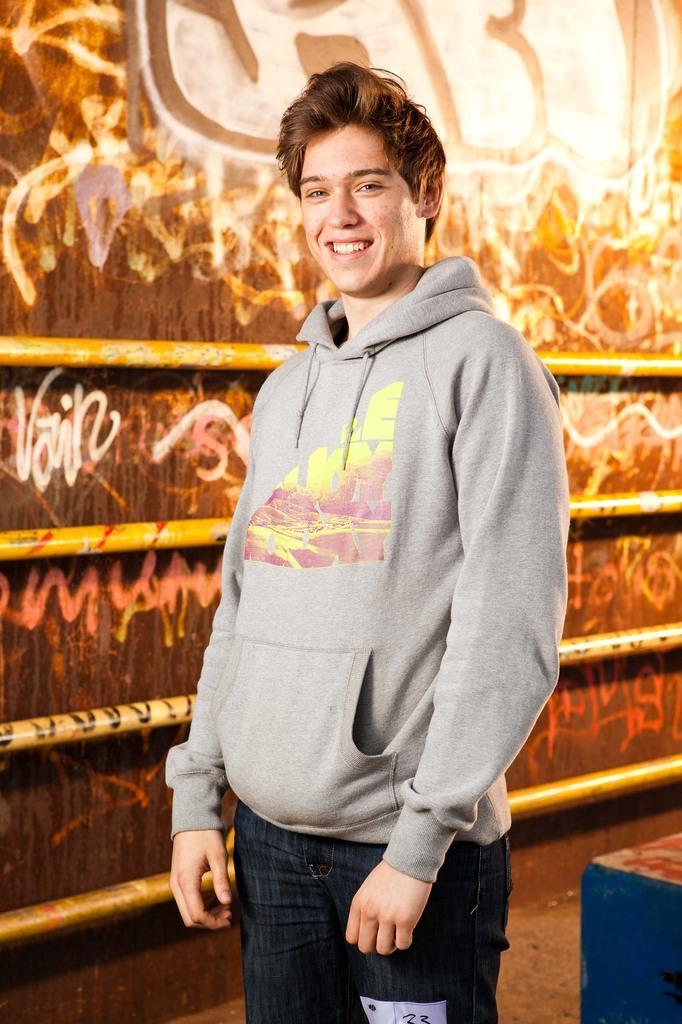Describe this image in one or two sentences. In this image, we can see a person standing. In the background, we can see the wall with some design and some objects attached to it. We can also see an object on the bottom right corner. 